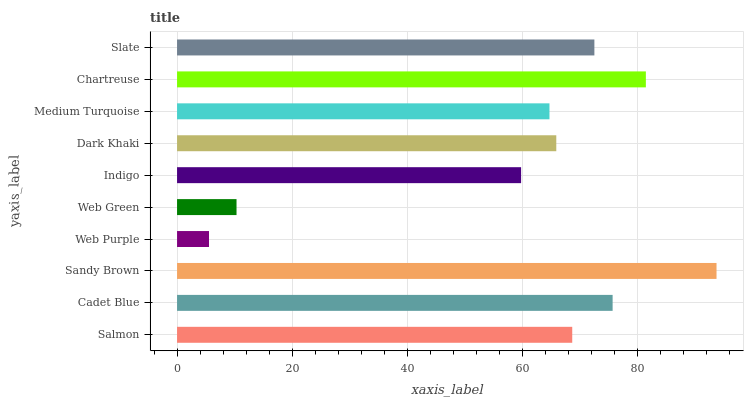Is Web Purple the minimum?
Answer yes or no. Yes. Is Sandy Brown the maximum?
Answer yes or no. Yes. Is Cadet Blue the minimum?
Answer yes or no. No. Is Cadet Blue the maximum?
Answer yes or no. No. Is Cadet Blue greater than Salmon?
Answer yes or no. Yes. Is Salmon less than Cadet Blue?
Answer yes or no. Yes. Is Salmon greater than Cadet Blue?
Answer yes or no. No. Is Cadet Blue less than Salmon?
Answer yes or no. No. Is Salmon the high median?
Answer yes or no. Yes. Is Dark Khaki the low median?
Answer yes or no. Yes. Is Web Purple the high median?
Answer yes or no. No. Is Web Purple the low median?
Answer yes or no. No. 